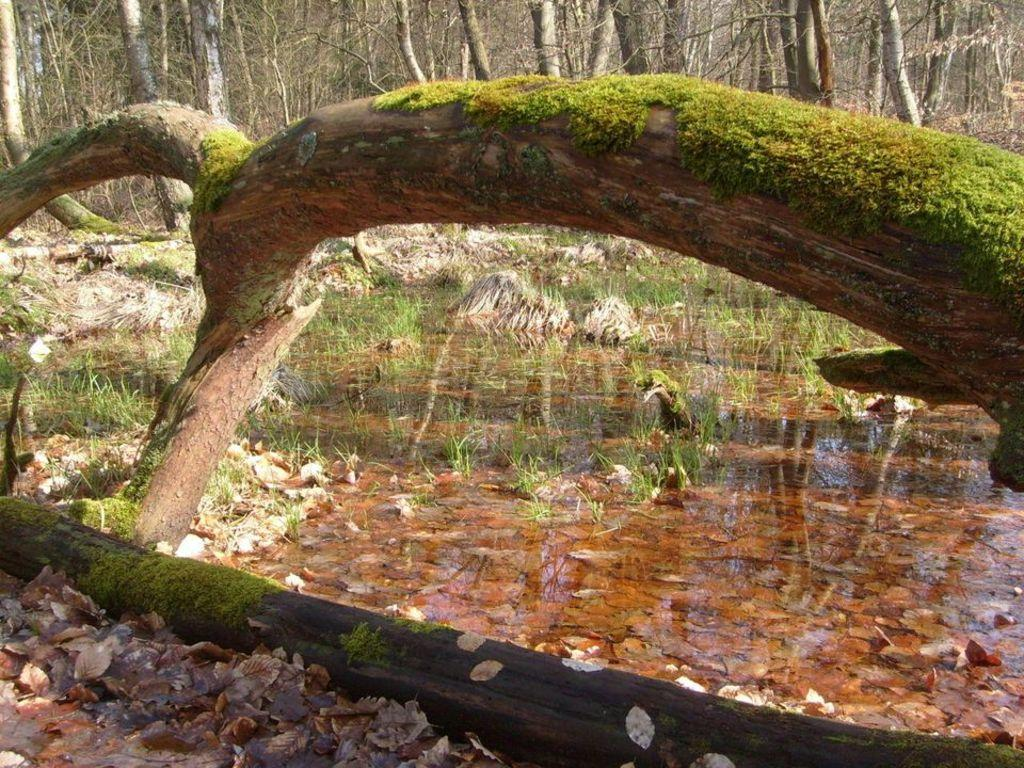What is the primary element visible in the image? There is water in the image. What type of vegetation can be seen in the image? There are trees in the image. What is floating in the water? There are dried leaves in the water. What is the writing on the leaves in the image? There is no writing on the leaves in the image; the leaves are dried and floating in the water. 